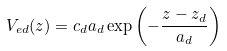Convert formula to latex. <formula><loc_0><loc_0><loc_500><loc_500>V _ { e d } ( z ) = c _ { d } a _ { d } \exp \left ( - \frac { z - z _ { d } } { a _ { d } } \right )</formula> 